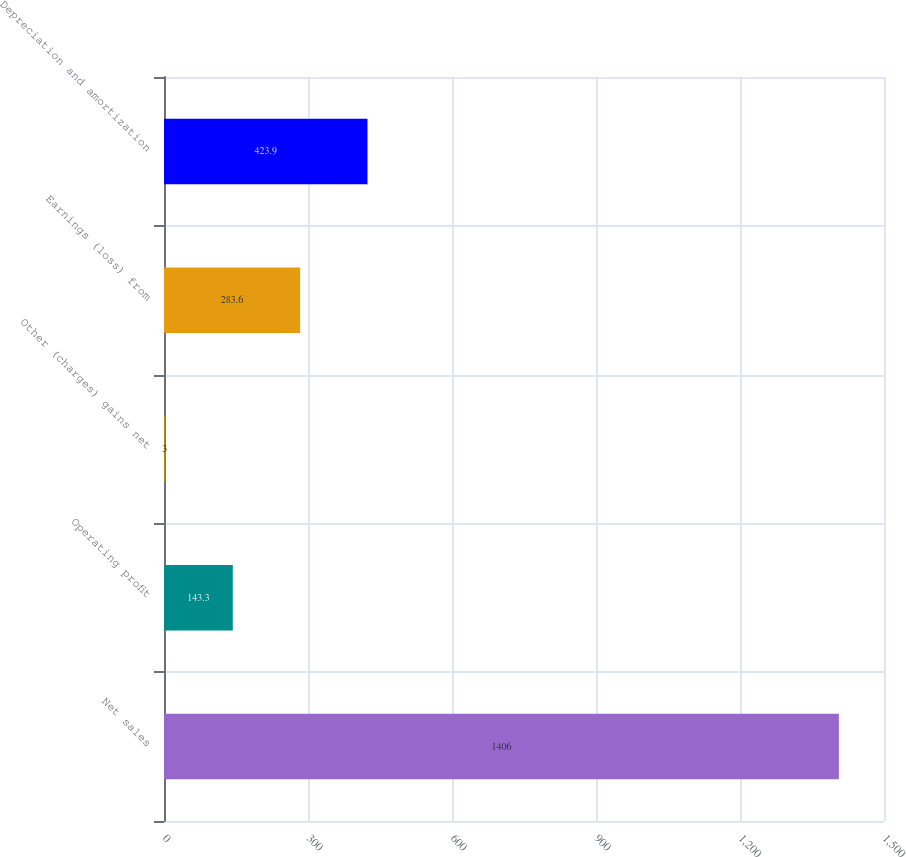<chart> <loc_0><loc_0><loc_500><loc_500><bar_chart><fcel>Net sales<fcel>Operating profit<fcel>Other (charges) gains net<fcel>Earnings (loss) from<fcel>Depreciation and amortization<nl><fcel>1406<fcel>143.3<fcel>3<fcel>283.6<fcel>423.9<nl></chart> 